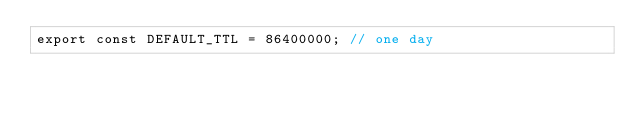<code> <loc_0><loc_0><loc_500><loc_500><_TypeScript_>export const DEFAULT_TTL = 86400000; // one day
</code> 